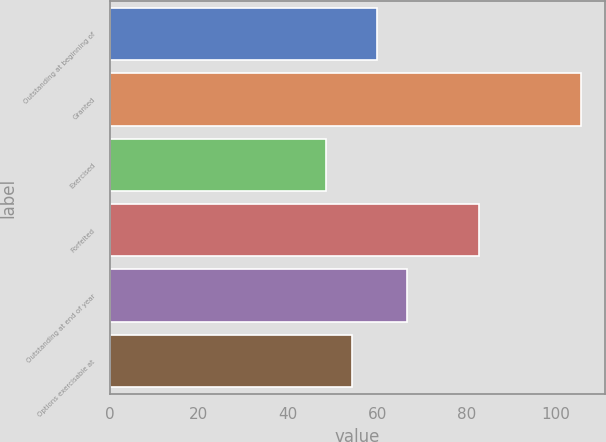Convert chart. <chart><loc_0><loc_0><loc_500><loc_500><bar_chart><fcel>Outstanding at beginning of<fcel>Granted<fcel>Exercised<fcel>Forfeited<fcel>Outstanding at end of year<fcel>Options exercisable at<nl><fcel>60.03<fcel>105.75<fcel>48.61<fcel>82.8<fcel>66.69<fcel>54.32<nl></chart> 